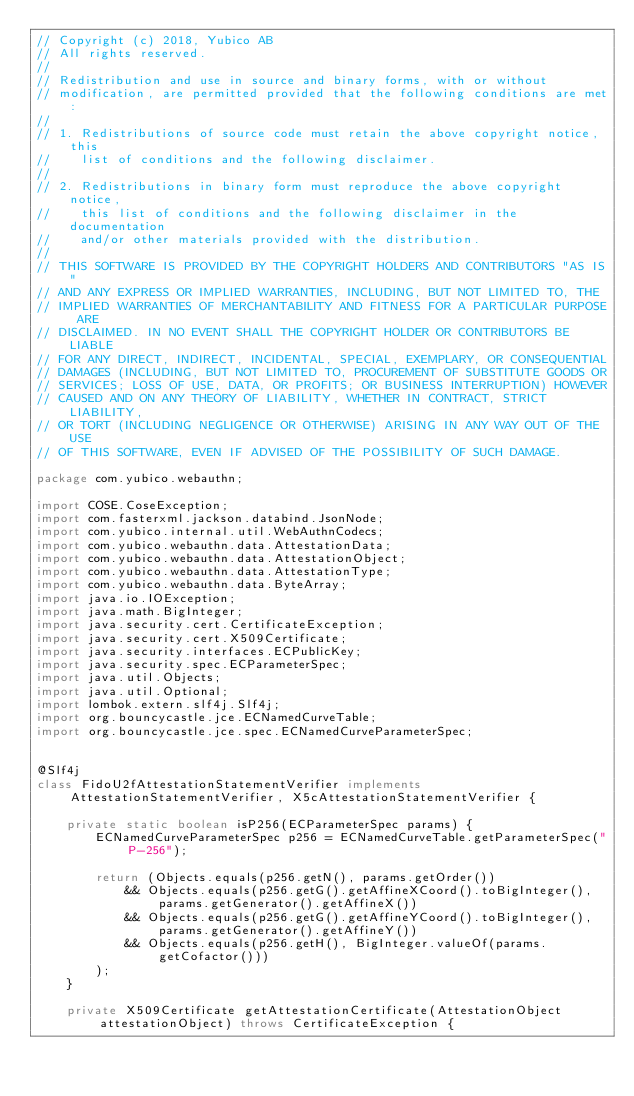<code> <loc_0><loc_0><loc_500><loc_500><_Java_>// Copyright (c) 2018, Yubico AB
// All rights reserved.
//
// Redistribution and use in source and binary forms, with or without
// modification, are permitted provided that the following conditions are met:
//
// 1. Redistributions of source code must retain the above copyright notice, this
//    list of conditions and the following disclaimer.
//
// 2. Redistributions in binary form must reproduce the above copyright notice,
//    this list of conditions and the following disclaimer in the documentation
//    and/or other materials provided with the distribution.
//
// THIS SOFTWARE IS PROVIDED BY THE COPYRIGHT HOLDERS AND CONTRIBUTORS "AS IS"
// AND ANY EXPRESS OR IMPLIED WARRANTIES, INCLUDING, BUT NOT LIMITED TO, THE
// IMPLIED WARRANTIES OF MERCHANTABILITY AND FITNESS FOR A PARTICULAR PURPOSE ARE
// DISCLAIMED. IN NO EVENT SHALL THE COPYRIGHT HOLDER OR CONTRIBUTORS BE LIABLE
// FOR ANY DIRECT, INDIRECT, INCIDENTAL, SPECIAL, EXEMPLARY, OR CONSEQUENTIAL
// DAMAGES (INCLUDING, BUT NOT LIMITED TO, PROCUREMENT OF SUBSTITUTE GOODS OR
// SERVICES; LOSS OF USE, DATA, OR PROFITS; OR BUSINESS INTERRUPTION) HOWEVER
// CAUSED AND ON ANY THEORY OF LIABILITY, WHETHER IN CONTRACT, STRICT LIABILITY,
// OR TORT (INCLUDING NEGLIGENCE OR OTHERWISE) ARISING IN ANY WAY OUT OF THE USE
// OF THIS SOFTWARE, EVEN IF ADVISED OF THE POSSIBILITY OF SUCH DAMAGE.

package com.yubico.webauthn;

import COSE.CoseException;
import com.fasterxml.jackson.databind.JsonNode;
import com.yubico.internal.util.WebAuthnCodecs;
import com.yubico.webauthn.data.AttestationData;
import com.yubico.webauthn.data.AttestationObject;
import com.yubico.webauthn.data.AttestationType;
import com.yubico.webauthn.data.ByteArray;
import java.io.IOException;
import java.math.BigInteger;
import java.security.cert.CertificateException;
import java.security.cert.X509Certificate;
import java.security.interfaces.ECPublicKey;
import java.security.spec.ECParameterSpec;
import java.util.Objects;
import java.util.Optional;
import lombok.extern.slf4j.Slf4j;
import org.bouncycastle.jce.ECNamedCurveTable;
import org.bouncycastle.jce.spec.ECNamedCurveParameterSpec;


@Slf4j
class FidoU2fAttestationStatementVerifier implements AttestationStatementVerifier, X5cAttestationStatementVerifier {

    private static boolean isP256(ECParameterSpec params) {
        ECNamedCurveParameterSpec p256 = ECNamedCurveTable.getParameterSpec("P-256");

        return (Objects.equals(p256.getN(), params.getOrder())
            && Objects.equals(p256.getG().getAffineXCoord().toBigInteger(), params.getGenerator().getAffineX())
            && Objects.equals(p256.getG().getAffineYCoord().toBigInteger(), params.getGenerator().getAffineY())
            && Objects.equals(p256.getH(), BigInteger.valueOf(params.getCofactor()))
        );
    }

    private X509Certificate getAttestationCertificate(AttestationObject attestationObject) throws CertificateException {</code> 